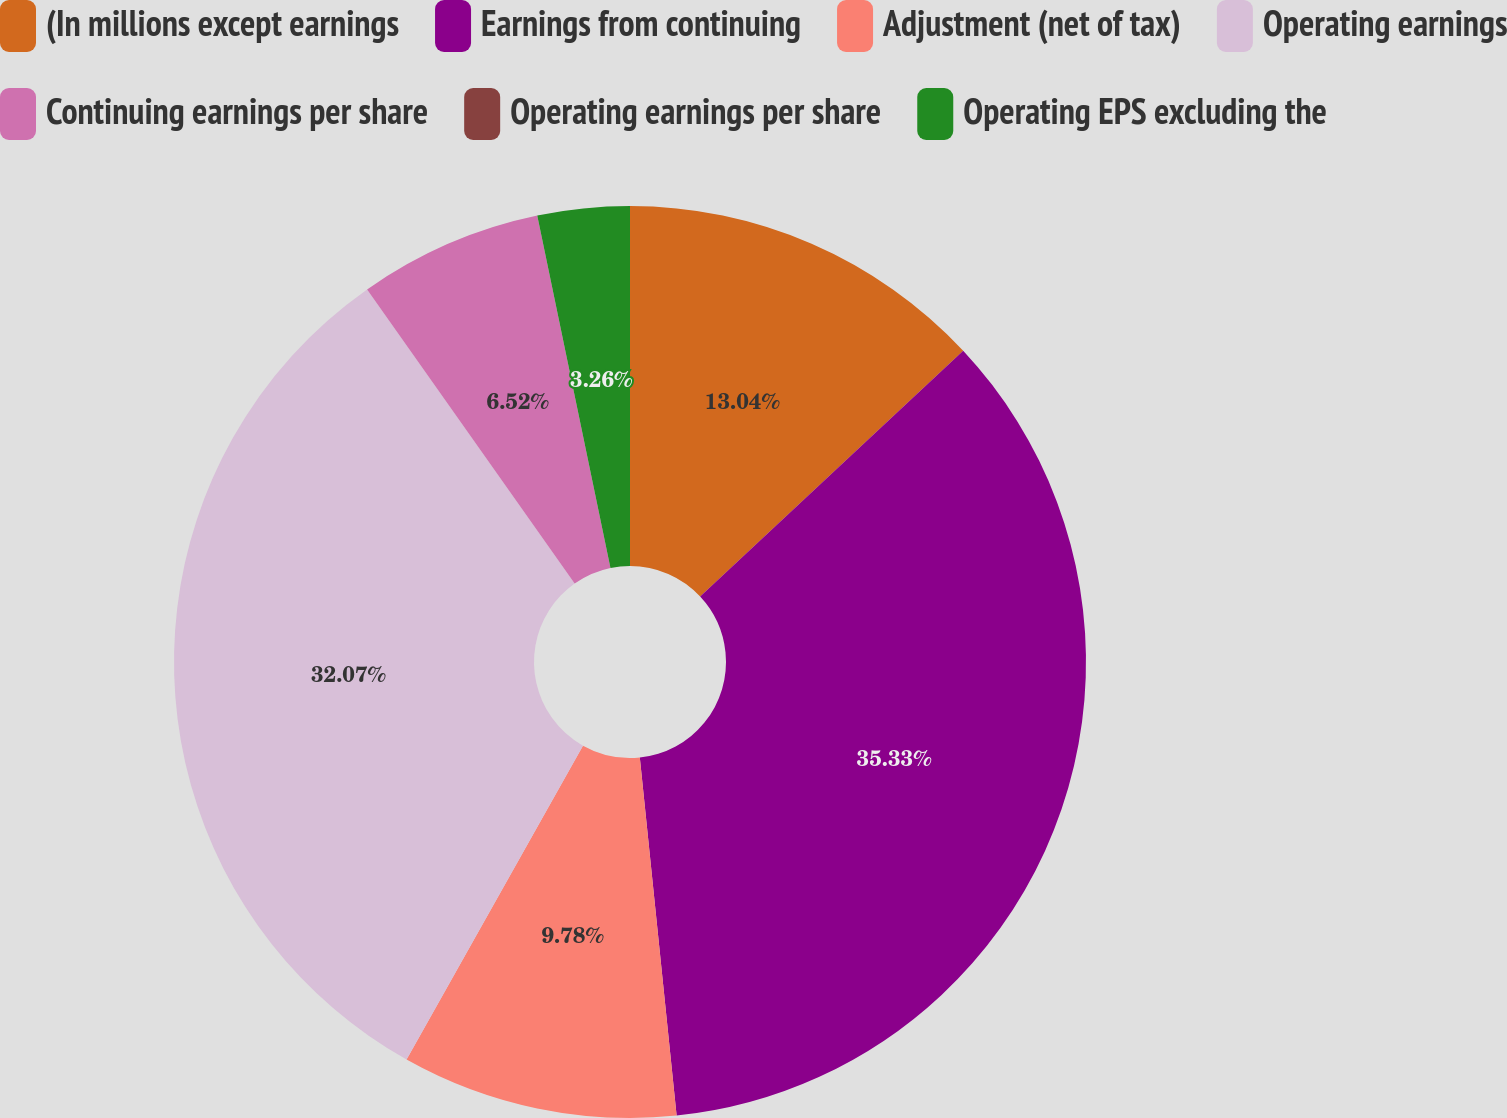Convert chart to OTSL. <chart><loc_0><loc_0><loc_500><loc_500><pie_chart><fcel>(In millions except earnings<fcel>Earnings from continuing<fcel>Adjustment (net of tax)<fcel>Operating earnings<fcel>Continuing earnings per share<fcel>Operating earnings per share<fcel>Operating EPS excluding the<nl><fcel>13.04%<fcel>35.33%<fcel>9.78%<fcel>32.07%<fcel>6.52%<fcel>0.0%<fcel>3.26%<nl></chart> 